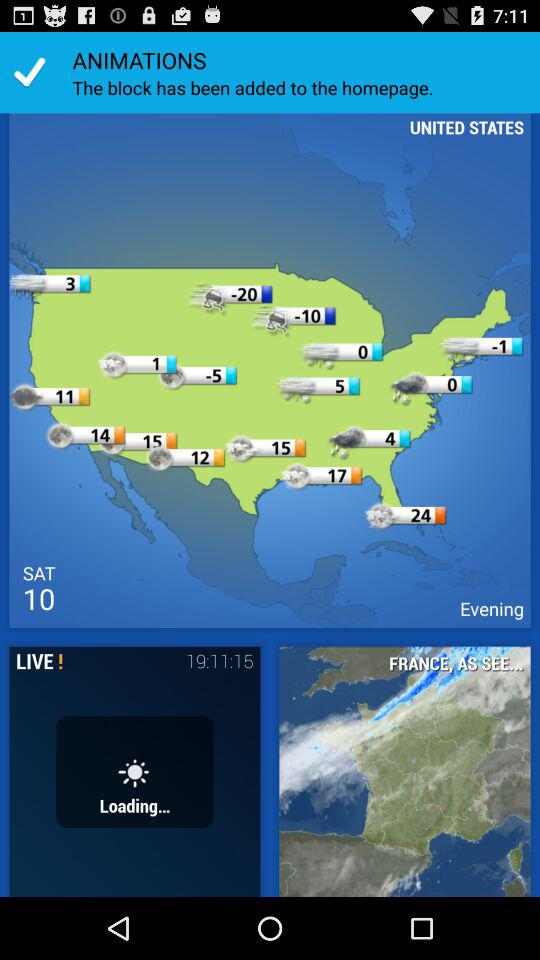What is the mentioned date? The date is Saturday, the 10th. 